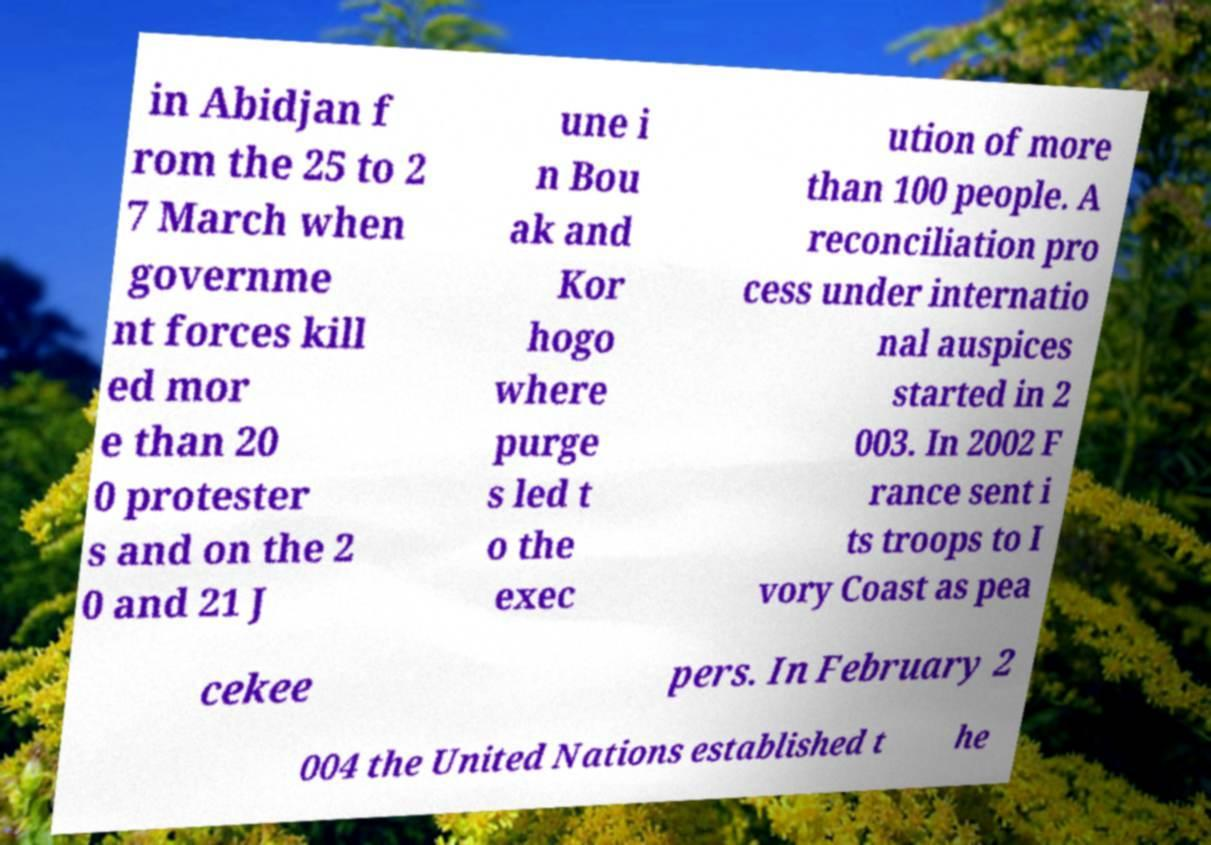What messages or text are displayed in this image? I need them in a readable, typed format. in Abidjan f rom the 25 to 2 7 March when governme nt forces kill ed mor e than 20 0 protester s and on the 2 0 and 21 J une i n Bou ak and Kor hogo where purge s led t o the exec ution of more than 100 people. A reconciliation pro cess under internatio nal auspices started in 2 003. In 2002 F rance sent i ts troops to I vory Coast as pea cekee pers. In February 2 004 the United Nations established t he 